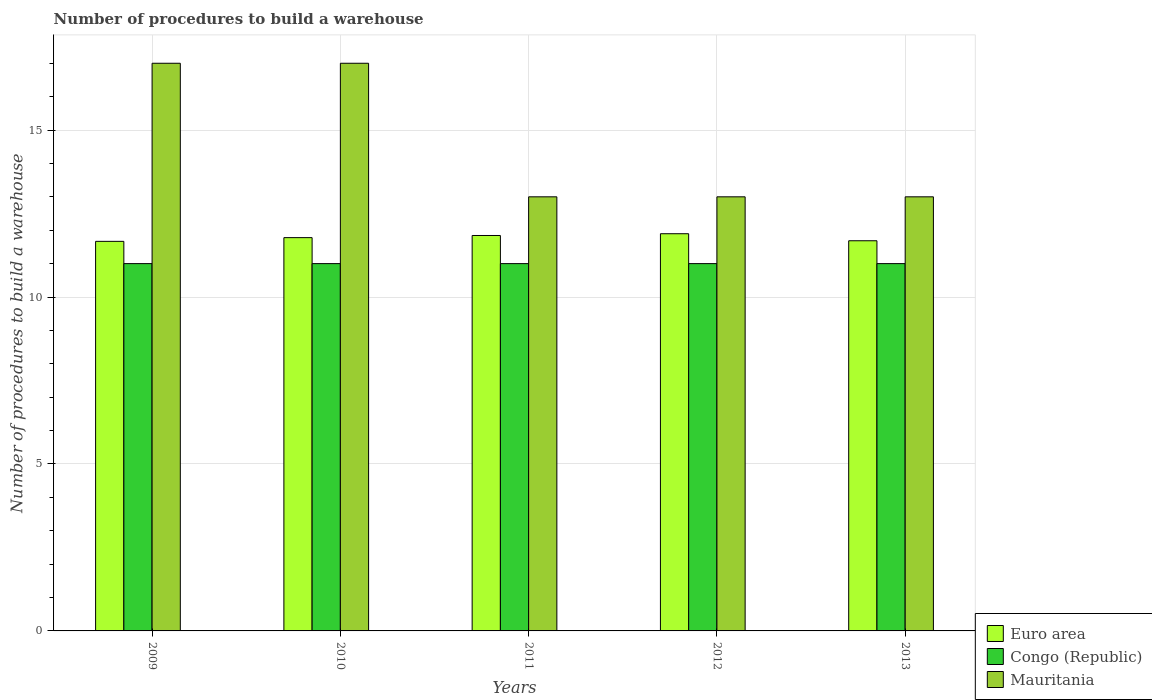How many different coloured bars are there?
Your answer should be very brief. 3. How many groups of bars are there?
Your answer should be compact. 5. Are the number of bars per tick equal to the number of legend labels?
Make the answer very short. Yes. Are the number of bars on each tick of the X-axis equal?
Keep it short and to the point. Yes. How many bars are there on the 2nd tick from the right?
Your answer should be very brief. 3. In how many cases, is the number of bars for a given year not equal to the number of legend labels?
Ensure brevity in your answer.  0. What is the number of procedures to build a warehouse in in Mauritania in 2011?
Ensure brevity in your answer.  13. Across all years, what is the maximum number of procedures to build a warehouse in in Congo (Republic)?
Your response must be concise. 11. Across all years, what is the minimum number of procedures to build a warehouse in in Congo (Republic)?
Offer a terse response. 11. In which year was the number of procedures to build a warehouse in in Euro area minimum?
Offer a terse response. 2009. What is the total number of procedures to build a warehouse in in Euro area in the graph?
Ensure brevity in your answer.  58.87. What is the difference between the number of procedures to build a warehouse in in Mauritania in 2009 and that in 2013?
Provide a succinct answer. 4. What is the difference between the number of procedures to build a warehouse in in Mauritania in 2010 and the number of procedures to build a warehouse in in Euro area in 2013?
Your answer should be very brief. 5.32. What is the average number of procedures to build a warehouse in in Euro area per year?
Your answer should be compact. 11.77. In the year 2013, what is the difference between the number of procedures to build a warehouse in in Mauritania and number of procedures to build a warehouse in in Congo (Republic)?
Give a very brief answer. 2. In how many years, is the number of procedures to build a warehouse in in Euro area greater than 10?
Your response must be concise. 5. What is the ratio of the number of procedures to build a warehouse in in Congo (Republic) in 2010 to that in 2012?
Offer a terse response. 1. Is the number of procedures to build a warehouse in in Euro area in 2010 less than that in 2011?
Your response must be concise. Yes. What is the difference between the highest and the second highest number of procedures to build a warehouse in in Mauritania?
Offer a very short reply. 0. What is the difference between the highest and the lowest number of procedures to build a warehouse in in Mauritania?
Ensure brevity in your answer.  4. What does the 2nd bar from the left in 2011 represents?
Your answer should be very brief. Congo (Republic). What does the 1st bar from the right in 2011 represents?
Your response must be concise. Mauritania. How many years are there in the graph?
Your response must be concise. 5. Are the values on the major ticks of Y-axis written in scientific E-notation?
Make the answer very short. No. Does the graph contain grids?
Give a very brief answer. Yes. What is the title of the graph?
Keep it short and to the point. Number of procedures to build a warehouse. Does "Suriname" appear as one of the legend labels in the graph?
Provide a succinct answer. No. What is the label or title of the Y-axis?
Offer a very short reply. Number of procedures to build a warehouse. What is the Number of procedures to build a warehouse of Euro area in 2009?
Make the answer very short. 11.67. What is the Number of procedures to build a warehouse of Congo (Republic) in 2009?
Give a very brief answer. 11. What is the Number of procedures to build a warehouse in Mauritania in 2009?
Provide a short and direct response. 17. What is the Number of procedures to build a warehouse in Euro area in 2010?
Make the answer very short. 11.78. What is the Number of procedures to build a warehouse in Congo (Republic) in 2010?
Give a very brief answer. 11. What is the Number of procedures to build a warehouse of Mauritania in 2010?
Your response must be concise. 17. What is the Number of procedures to build a warehouse in Euro area in 2011?
Your answer should be very brief. 11.84. What is the Number of procedures to build a warehouse of Euro area in 2012?
Your response must be concise. 11.89. What is the Number of procedures to build a warehouse of Euro area in 2013?
Keep it short and to the point. 11.68. Across all years, what is the maximum Number of procedures to build a warehouse of Euro area?
Your response must be concise. 11.89. Across all years, what is the minimum Number of procedures to build a warehouse of Euro area?
Your answer should be very brief. 11.67. Across all years, what is the minimum Number of procedures to build a warehouse in Congo (Republic)?
Provide a succinct answer. 11. Across all years, what is the minimum Number of procedures to build a warehouse of Mauritania?
Your answer should be very brief. 13. What is the total Number of procedures to build a warehouse of Euro area in the graph?
Your response must be concise. 58.87. What is the difference between the Number of procedures to build a warehouse of Euro area in 2009 and that in 2010?
Offer a very short reply. -0.11. What is the difference between the Number of procedures to build a warehouse of Congo (Republic) in 2009 and that in 2010?
Give a very brief answer. 0. What is the difference between the Number of procedures to build a warehouse of Mauritania in 2009 and that in 2010?
Keep it short and to the point. 0. What is the difference between the Number of procedures to build a warehouse of Euro area in 2009 and that in 2011?
Provide a short and direct response. -0.18. What is the difference between the Number of procedures to build a warehouse of Mauritania in 2009 and that in 2011?
Your answer should be very brief. 4. What is the difference between the Number of procedures to build a warehouse of Euro area in 2009 and that in 2012?
Your answer should be compact. -0.23. What is the difference between the Number of procedures to build a warehouse in Euro area in 2009 and that in 2013?
Provide a short and direct response. -0.02. What is the difference between the Number of procedures to build a warehouse in Congo (Republic) in 2009 and that in 2013?
Give a very brief answer. 0. What is the difference between the Number of procedures to build a warehouse in Mauritania in 2009 and that in 2013?
Provide a short and direct response. 4. What is the difference between the Number of procedures to build a warehouse in Euro area in 2010 and that in 2011?
Offer a terse response. -0.06. What is the difference between the Number of procedures to build a warehouse in Mauritania in 2010 and that in 2011?
Offer a terse response. 4. What is the difference between the Number of procedures to build a warehouse in Euro area in 2010 and that in 2012?
Offer a very short reply. -0.12. What is the difference between the Number of procedures to build a warehouse of Mauritania in 2010 and that in 2012?
Offer a very short reply. 4. What is the difference between the Number of procedures to build a warehouse of Euro area in 2010 and that in 2013?
Make the answer very short. 0.09. What is the difference between the Number of procedures to build a warehouse in Congo (Republic) in 2010 and that in 2013?
Provide a succinct answer. 0. What is the difference between the Number of procedures to build a warehouse in Mauritania in 2010 and that in 2013?
Your response must be concise. 4. What is the difference between the Number of procedures to build a warehouse of Euro area in 2011 and that in 2012?
Provide a succinct answer. -0.05. What is the difference between the Number of procedures to build a warehouse in Congo (Republic) in 2011 and that in 2012?
Offer a terse response. 0. What is the difference between the Number of procedures to build a warehouse in Mauritania in 2011 and that in 2012?
Ensure brevity in your answer.  0. What is the difference between the Number of procedures to build a warehouse of Euro area in 2011 and that in 2013?
Offer a very short reply. 0.16. What is the difference between the Number of procedures to build a warehouse in Euro area in 2012 and that in 2013?
Offer a very short reply. 0.21. What is the difference between the Number of procedures to build a warehouse of Congo (Republic) in 2012 and that in 2013?
Your answer should be compact. 0. What is the difference between the Number of procedures to build a warehouse in Euro area in 2009 and the Number of procedures to build a warehouse in Congo (Republic) in 2010?
Give a very brief answer. 0.67. What is the difference between the Number of procedures to build a warehouse in Euro area in 2009 and the Number of procedures to build a warehouse in Mauritania in 2010?
Offer a terse response. -5.33. What is the difference between the Number of procedures to build a warehouse of Euro area in 2009 and the Number of procedures to build a warehouse of Mauritania in 2011?
Ensure brevity in your answer.  -1.33. What is the difference between the Number of procedures to build a warehouse in Congo (Republic) in 2009 and the Number of procedures to build a warehouse in Mauritania in 2011?
Provide a short and direct response. -2. What is the difference between the Number of procedures to build a warehouse in Euro area in 2009 and the Number of procedures to build a warehouse in Mauritania in 2012?
Offer a terse response. -1.33. What is the difference between the Number of procedures to build a warehouse in Congo (Republic) in 2009 and the Number of procedures to build a warehouse in Mauritania in 2012?
Provide a short and direct response. -2. What is the difference between the Number of procedures to build a warehouse of Euro area in 2009 and the Number of procedures to build a warehouse of Congo (Republic) in 2013?
Ensure brevity in your answer.  0.67. What is the difference between the Number of procedures to build a warehouse of Euro area in 2009 and the Number of procedures to build a warehouse of Mauritania in 2013?
Your answer should be very brief. -1.33. What is the difference between the Number of procedures to build a warehouse in Congo (Republic) in 2009 and the Number of procedures to build a warehouse in Mauritania in 2013?
Offer a very short reply. -2. What is the difference between the Number of procedures to build a warehouse in Euro area in 2010 and the Number of procedures to build a warehouse in Congo (Republic) in 2011?
Provide a short and direct response. 0.78. What is the difference between the Number of procedures to build a warehouse of Euro area in 2010 and the Number of procedures to build a warehouse of Mauritania in 2011?
Provide a short and direct response. -1.22. What is the difference between the Number of procedures to build a warehouse in Congo (Republic) in 2010 and the Number of procedures to build a warehouse in Mauritania in 2011?
Provide a short and direct response. -2. What is the difference between the Number of procedures to build a warehouse of Euro area in 2010 and the Number of procedures to build a warehouse of Congo (Republic) in 2012?
Your response must be concise. 0.78. What is the difference between the Number of procedures to build a warehouse of Euro area in 2010 and the Number of procedures to build a warehouse of Mauritania in 2012?
Offer a terse response. -1.22. What is the difference between the Number of procedures to build a warehouse of Congo (Republic) in 2010 and the Number of procedures to build a warehouse of Mauritania in 2012?
Give a very brief answer. -2. What is the difference between the Number of procedures to build a warehouse of Euro area in 2010 and the Number of procedures to build a warehouse of Congo (Republic) in 2013?
Provide a succinct answer. 0.78. What is the difference between the Number of procedures to build a warehouse of Euro area in 2010 and the Number of procedures to build a warehouse of Mauritania in 2013?
Give a very brief answer. -1.22. What is the difference between the Number of procedures to build a warehouse in Congo (Republic) in 2010 and the Number of procedures to build a warehouse in Mauritania in 2013?
Provide a short and direct response. -2. What is the difference between the Number of procedures to build a warehouse in Euro area in 2011 and the Number of procedures to build a warehouse in Congo (Republic) in 2012?
Provide a short and direct response. 0.84. What is the difference between the Number of procedures to build a warehouse of Euro area in 2011 and the Number of procedures to build a warehouse of Mauritania in 2012?
Keep it short and to the point. -1.16. What is the difference between the Number of procedures to build a warehouse in Euro area in 2011 and the Number of procedures to build a warehouse in Congo (Republic) in 2013?
Give a very brief answer. 0.84. What is the difference between the Number of procedures to build a warehouse of Euro area in 2011 and the Number of procedures to build a warehouse of Mauritania in 2013?
Your response must be concise. -1.16. What is the difference between the Number of procedures to build a warehouse of Congo (Republic) in 2011 and the Number of procedures to build a warehouse of Mauritania in 2013?
Offer a terse response. -2. What is the difference between the Number of procedures to build a warehouse in Euro area in 2012 and the Number of procedures to build a warehouse in Congo (Republic) in 2013?
Give a very brief answer. 0.89. What is the difference between the Number of procedures to build a warehouse of Euro area in 2012 and the Number of procedures to build a warehouse of Mauritania in 2013?
Your answer should be very brief. -1.11. What is the difference between the Number of procedures to build a warehouse in Congo (Republic) in 2012 and the Number of procedures to build a warehouse in Mauritania in 2013?
Your response must be concise. -2. What is the average Number of procedures to build a warehouse of Euro area per year?
Provide a succinct answer. 11.77. What is the average Number of procedures to build a warehouse in Mauritania per year?
Your answer should be very brief. 14.6. In the year 2009, what is the difference between the Number of procedures to build a warehouse of Euro area and Number of procedures to build a warehouse of Mauritania?
Your answer should be very brief. -5.33. In the year 2010, what is the difference between the Number of procedures to build a warehouse of Euro area and Number of procedures to build a warehouse of Mauritania?
Your answer should be compact. -5.22. In the year 2011, what is the difference between the Number of procedures to build a warehouse of Euro area and Number of procedures to build a warehouse of Congo (Republic)?
Keep it short and to the point. 0.84. In the year 2011, what is the difference between the Number of procedures to build a warehouse of Euro area and Number of procedures to build a warehouse of Mauritania?
Offer a terse response. -1.16. In the year 2011, what is the difference between the Number of procedures to build a warehouse of Congo (Republic) and Number of procedures to build a warehouse of Mauritania?
Your answer should be very brief. -2. In the year 2012, what is the difference between the Number of procedures to build a warehouse in Euro area and Number of procedures to build a warehouse in Congo (Republic)?
Ensure brevity in your answer.  0.89. In the year 2012, what is the difference between the Number of procedures to build a warehouse in Euro area and Number of procedures to build a warehouse in Mauritania?
Offer a terse response. -1.11. In the year 2013, what is the difference between the Number of procedures to build a warehouse of Euro area and Number of procedures to build a warehouse of Congo (Republic)?
Offer a terse response. 0.68. In the year 2013, what is the difference between the Number of procedures to build a warehouse in Euro area and Number of procedures to build a warehouse in Mauritania?
Your answer should be very brief. -1.32. In the year 2013, what is the difference between the Number of procedures to build a warehouse in Congo (Republic) and Number of procedures to build a warehouse in Mauritania?
Your answer should be very brief. -2. What is the ratio of the Number of procedures to build a warehouse of Euro area in 2009 to that in 2010?
Offer a very short reply. 0.99. What is the ratio of the Number of procedures to build a warehouse of Mauritania in 2009 to that in 2010?
Your answer should be compact. 1. What is the ratio of the Number of procedures to build a warehouse of Euro area in 2009 to that in 2011?
Your answer should be very brief. 0.99. What is the ratio of the Number of procedures to build a warehouse in Mauritania in 2009 to that in 2011?
Provide a succinct answer. 1.31. What is the ratio of the Number of procedures to build a warehouse of Euro area in 2009 to that in 2012?
Provide a succinct answer. 0.98. What is the ratio of the Number of procedures to build a warehouse in Mauritania in 2009 to that in 2012?
Offer a very short reply. 1.31. What is the ratio of the Number of procedures to build a warehouse of Euro area in 2009 to that in 2013?
Offer a very short reply. 1. What is the ratio of the Number of procedures to build a warehouse of Mauritania in 2009 to that in 2013?
Offer a terse response. 1.31. What is the ratio of the Number of procedures to build a warehouse of Congo (Republic) in 2010 to that in 2011?
Keep it short and to the point. 1. What is the ratio of the Number of procedures to build a warehouse of Mauritania in 2010 to that in 2011?
Keep it short and to the point. 1.31. What is the ratio of the Number of procedures to build a warehouse in Euro area in 2010 to that in 2012?
Offer a terse response. 0.99. What is the ratio of the Number of procedures to build a warehouse in Mauritania in 2010 to that in 2012?
Provide a succinct answer. 1.31. What is the ratio of the Number of procedures to build a warehouse in Mauritania in 2010 to that in 2013?
Offer a terse response. 1.31. What is the ratio of the Number of procedures to build a warehouse of Euro area in 2011 to that in 2012?
Provide a short and direct response. 1. What is the ratio of the Number of procedures to build a warehouse in Euro area in 2011 to that in 2013?
Provide a succinct answer. 1.01. What is the ratio of the Number of procedures to build a warehouse of Mauritania in 2011 to that in 2013?
Your answer should be very brief. 1. What is the ratio of the Number of procedures to build a warehouse in Euro area in 2012 to that in 2013?
Provide a succinct answer. 1.02. What is the difference between the highest and the second highest Number of procedures to build a warehouse in Euro area?
Ensure brevity in your answer.  0.05. What is the difference between the highest and the lowest Number of procedures to build a warehouse in Euro area?
Keep it short and to the point. 0.23. What is the difference between the highest and the lowest Number of procedures to build a warehouse in Congo (Republic)?
Offer a terse response. 0. 